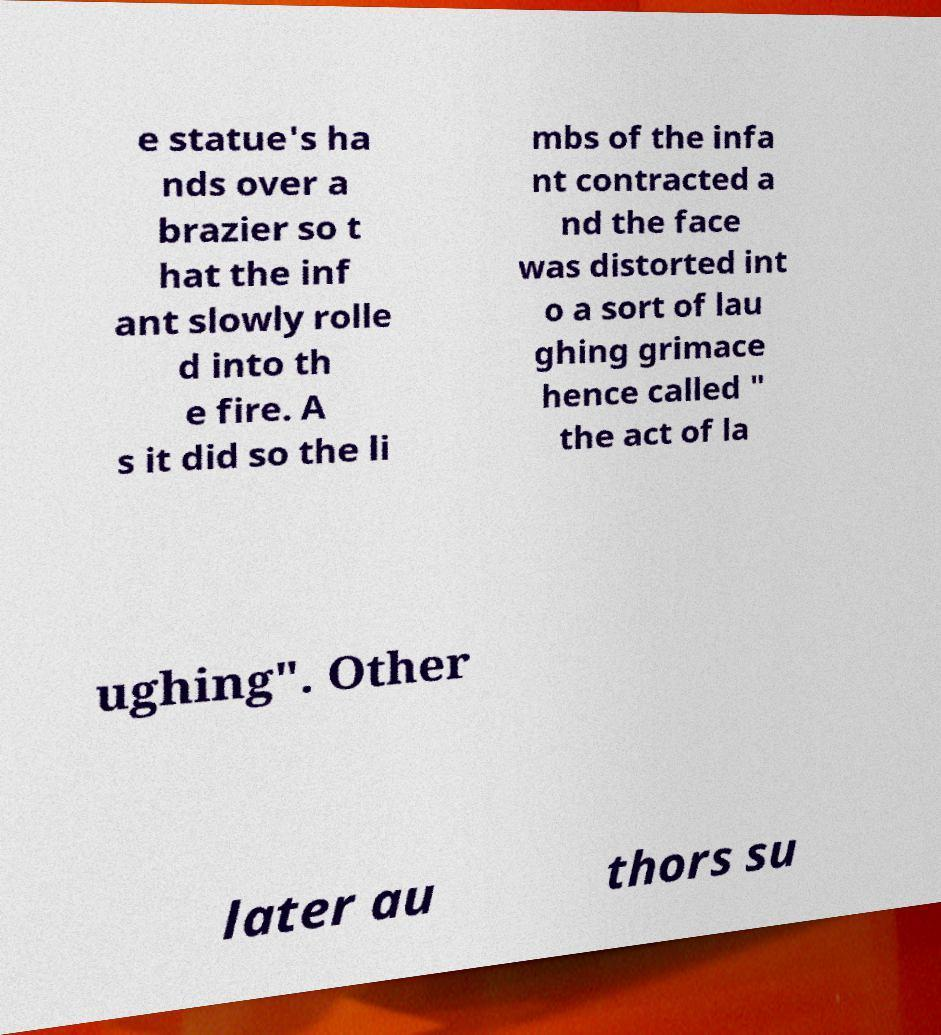Please identify and transcribe the text found in this image. e statue's ha nds over a brazier so t hat the inf ant slowly rolle d into th e fire. A s it did so the li mbs of the infa nt contracted a nd the face was distorted int o a sort of lau ghing grimace hence called " the act of la ughing". Other later au thors su 